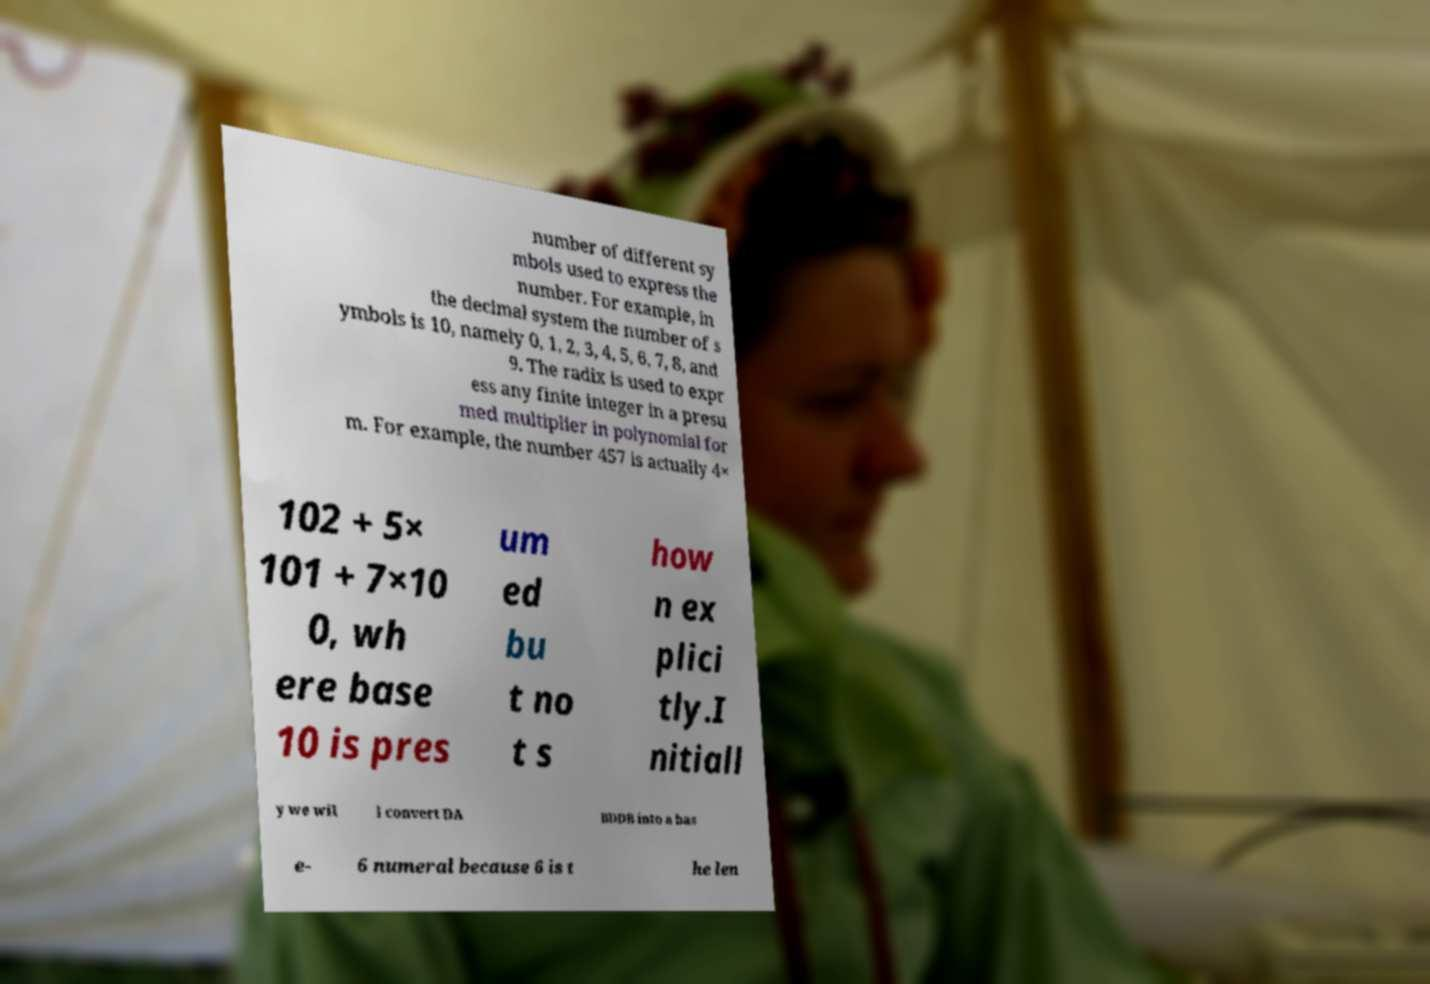What messages or text are displayed in this image? I need them in a readable, typed format. number of different sy mbols used to express the number. For example, in the decimal system the number of s ymbols is 10, namely 0, 1, 2, 3, 4, 5, 6, 7, 8, and 9. The radix is used to expr ess any finite integer in a presu med multiplier in polynomial for m. For example, the number 457 is actually 4× 102 + 5× 101 + 7×10 0, wh ere base 10 is pres um ed bu t no t s how n ex plici tly.I nitiall y we wil l convert DA BDDB into a bas e- 6 numeral because 6 is t he len 